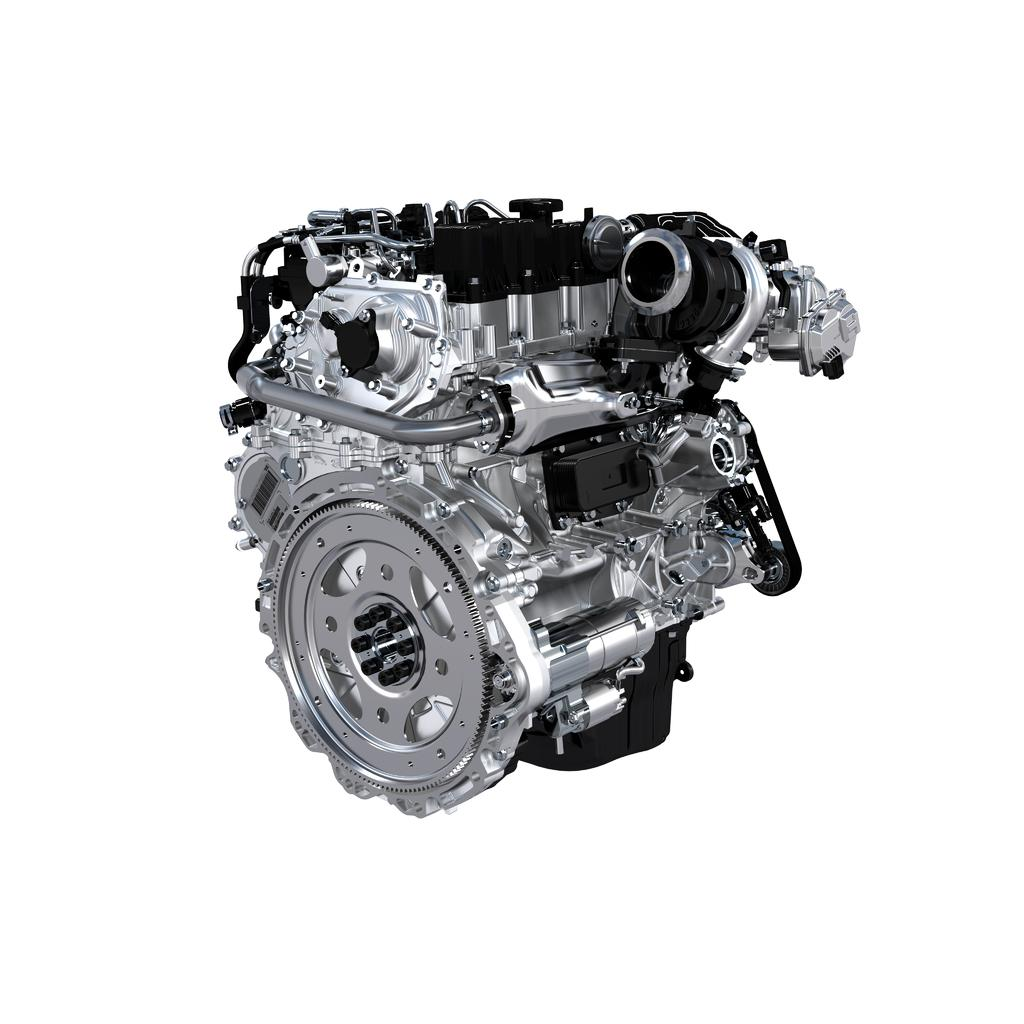What is the main subject of the image? The main subject of the image is a car engine. What color is the background of the image? The background of the image is white. What type of harmony is being played in the background of the image? There is no music or harmony present in the image; it features a car engine and a white background. 